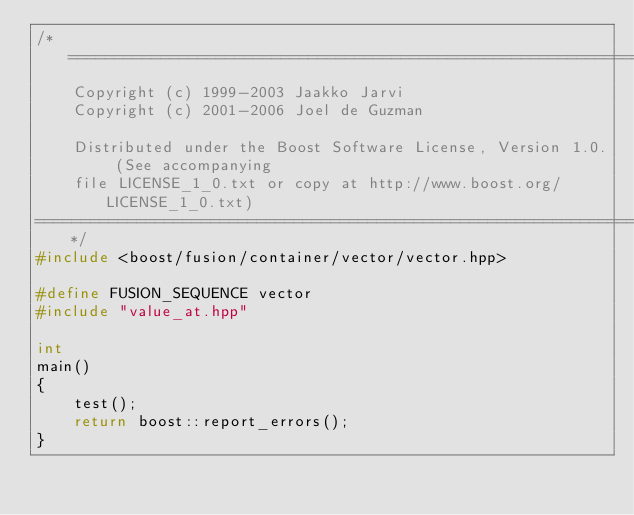<code> <loc_0><loc_0><loc_500><loc_500><_C++_>/*=============================================================================
    Copyright (c) 1999-2003 Jaakko Jarvi
    Copyright (c) 2001-2006 Joel de Guzman

    Distributed under the Boost Software License, Version 1.0. (See accompanying 
    file LICENSE_1_0.txt or copy at http://www.boost.org/LICENSE_1_0.txt)
==============================================================================*/
#include <boost/fusion/container/vector/vector.hpp>

#define FUSION_SEQUENCE vector
#include "value_at.hpp"

int
main()
{
    test();
    return boost::report_errors();
}

</code> 